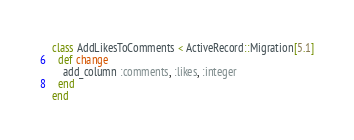Convert code to text. <code><loc_0><loc_0><loc_500><loc_500><_Ruby_>class AddLikesToComments < ActiveRecord::Migration[5.1]
  def change
    add_column :comments, :likes, :integer
  end
end
</code> 